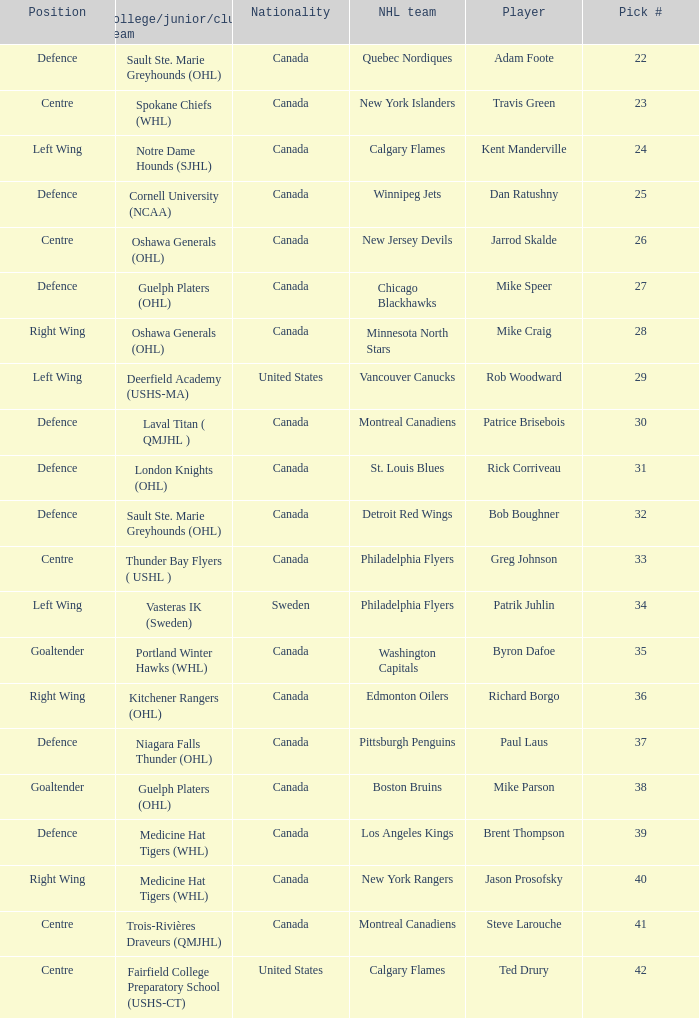What is the nationality of the draft pick player who plays centre position and is going to Calgary Flames? United States. 